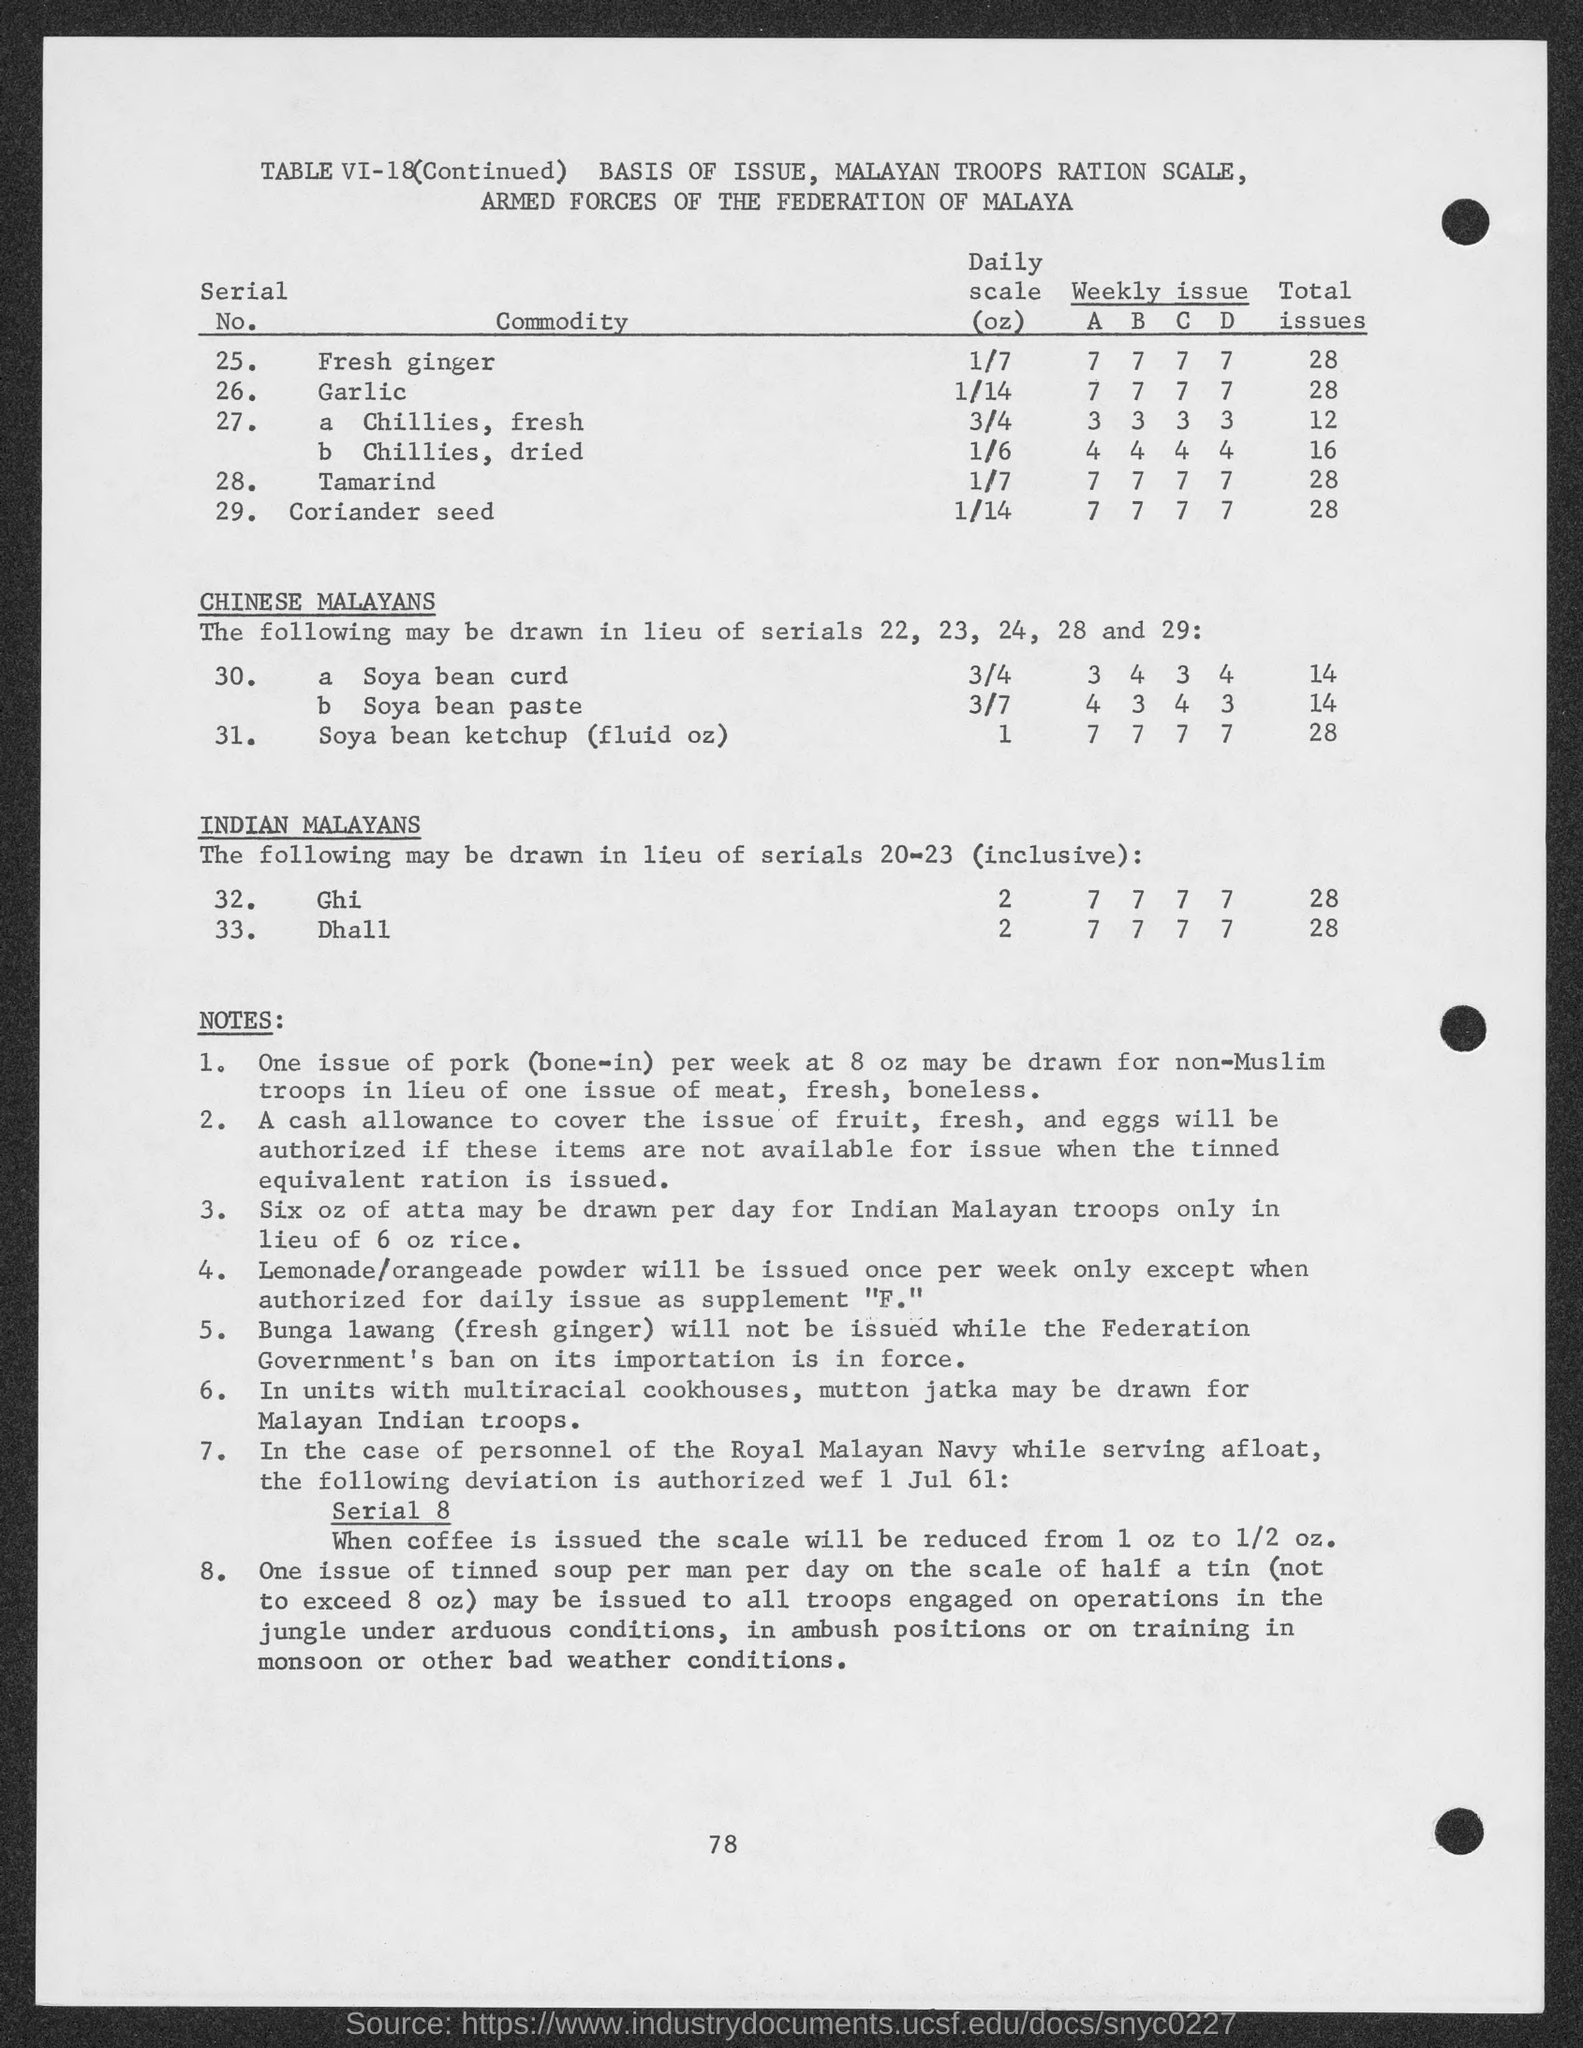What is the heading of the second column of the table?
Keep it short and to the point. Commodity. What is the heading of the last column of the table?
Your answer should be very brief. Total issues. What is the "serial no." of Garlic?
Your answer should be very brief. 26. What is the value of Daily Scale of ghi?
Your answer should be very brief. 2. What is the value of Daily Scale of dhall?
Your answer should be compact. 2. Mutton Jatka may be drawn for which troop?
Offer a terse response. Malayan Indian Troops. How many ounces of atta may be drawn per day?
Provide a short and direct response. Six. What is the value of "total issues" of tamarind?
Give a very brief answer. 28. What is the value of "total issues" of fresh ginger?
Your response must be concise. 28. What is the value of "total issues" of coriander seed?
Make the answer very short. 28. 